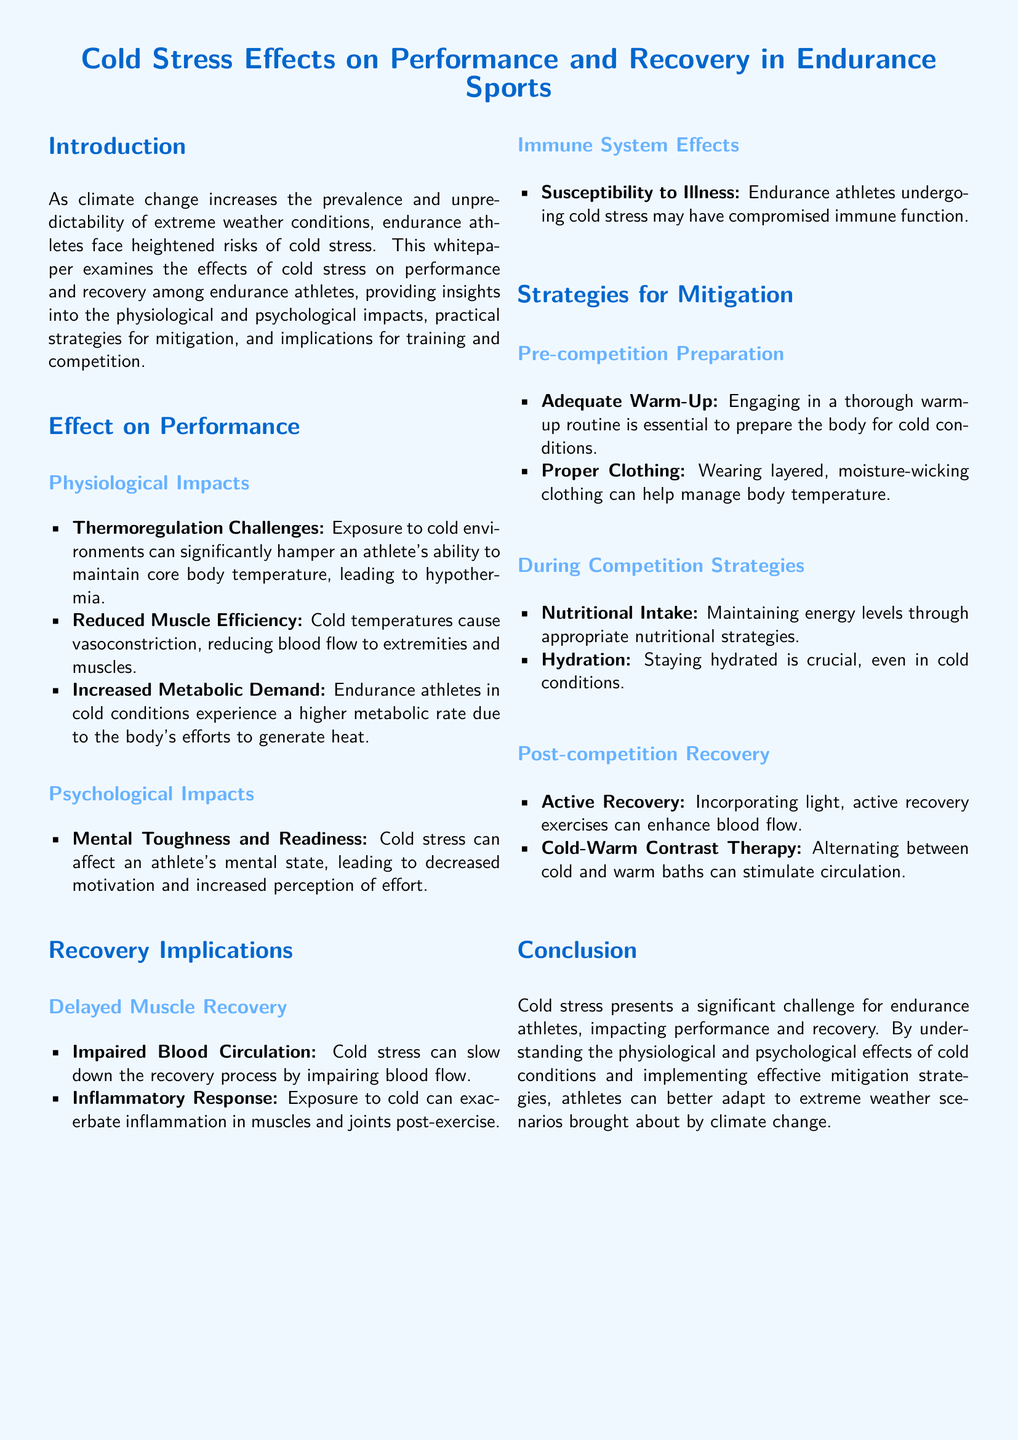what is the main focus of the whitepaper? The main focus of the whitepaper is to examine the effects of cold stress on performance and recovery among endurance athletes.
Answer: effects of cold stress on performance and recovery among endurance athletes what is one physiological impact of cold stress? The document lists multiple physiological impacts; one of them is a thermoregulation challenge that can lead to hypothermia.
Answer: thermoregulation challenges what can help manage body temperature during cold conditions? Proper clothing is mentioned as a strategy for managing body temperature, specifically wearing layered, moisture-wicking clothing.
Answer: layered, moisture-wicking clothing what is a recommended strategy for post-competition recovery? The document suggests active recovery exercises to enhance blood flow as a strategy for post-competition recovery.
Answer: active recovery what effect does cold stress have on the immune system? Cold stress can compromise immune function, making athletes more susceptible to illness.
Answer: compromised immune function how does cold temperature affect muscle efficiency? The document states that cold temperatures cause vasoconstriction, reducing blood flow to extremities and muscles, which impacts muscle efficiency.
Answer: reduced blood flow to extremities and muscles what should athletes maintain during competition in cold conditions? Athletes should maintain hydration during competition even in cold conditions.
Answer: hydration what is one psychological impact mentioned in the whitepaper? The whitepaper mentions that cold stress can lead to decreased motivation and increased perception of effort as a psychological impact.
Answer: decreased motivation why is a warm-up routine essential before competing in cold environments? A warm-up routine is essential to prepare the body for cold conditions, helping to mitigate cold stress effects.
Answer: to prepare the body for cold conditions 